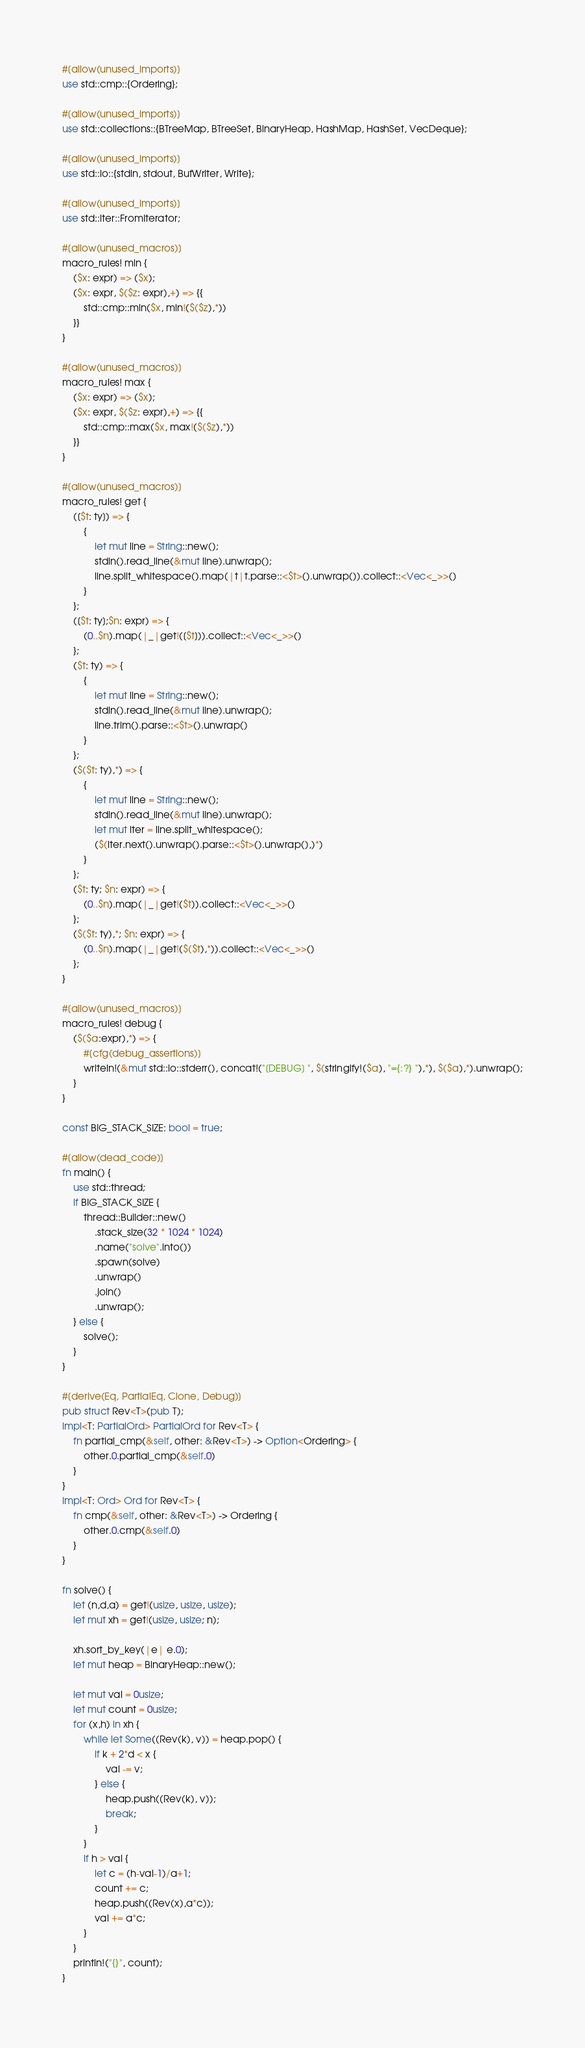Convert code to text. <code><loc_0><loc_0><loc_500><loc_500><_Rust_>#[allow(unused_imports)]
use std::cmp::{Ordering};

#[allow(unused_imports)]
use std::collections::{BTreeMap, BTreeSet, BinaryHeap, HashMap, HashSet, VecDeque};

#[allow(unused_imports)]
use std::io::{stdin, stdout, BufWriter, Write};

#[allow(unused_imports)]
use std::iter::FromIterator;

#[allow(unused_macros)]
macro_rules! min {
    ($x: expr) => ($x);
    ($x: expr, $($z: expr),+) => {{
        std::cmp::min($x, min!($($z),*))
    }}
}

#[allow(unused_macros)]
macro_rules! max {
    ($x: expr) => ($x);
    ($x: expr, $($z: expr),+) => {{
        std::cmp::max($x, max!($($z),*))
    }}
}

#[allow(unused_macros)]
macro_rules! get { 
    ([$t: ty]) => { 
        { 
            let mut line = String::new(); 
            stdin().read_line(&mut line).unwrap(); 
            line.split_whitespace().map(|t|t.parse::<$t>().unwrap()).collect::<Vec<_>>()
        }
    };
    ([$t: ty];$n: expr) => {
        (0..$n).map(|_|get!([$t])).collect::<Vec<_>>()
    };
    ($t: ty) => {
        {
            let mut line = String::new();
            stdin().read_line(&mut line).unwrap();
            line.trim().parse::<$t>().unwrap()
        }
    };
    ($($t: ty),*) => {
        { 
            let mut line = String::new();
            stdin().read_line(&mut line).unwrap();
            let mut iter = line.split_whitespace();
            ($(iter.next().unwrap().parse::<$t>().unwrap(),)*)
        }
    };
    ($t: ty; $n: expr) => {
        (0..$n).map(|_|get!($t)).collect::<Vec<_>>()
    };
    ($($t: ty),*; $n: expr) => {
        (0..$n).map(|_|get!($($t),*)).collect::<Vec<_>>()
    };
}

#[allow(unused_macros)]
macro_rules! debug {
    ($($a:expr),*) => {
        #[cfg(debug_assertions)]
        writeln!(&mut std::io::stderr(), concat!("[DEBUG] ", $(stringify!($a), "={:?} "),*), $($a),*).unwrap();
    }
}

const BIG_STACK_SIZE: bool = true;

#[allow(dead_code)]
fn main() {
    use std::thread;
    if BIG_STACK_SIZE {
        thread::Builder::new()
            .stack_size(32 * 1024 * 1024)
            .name("solve".into())
            .spawn(solve)
            .unwrap()
            .join()
            .unwrap();
    } else {
        solve();
    }
}

#[derive(Eq, PartialEq, Clone, Debug)]
pub struct Rev<T>(pub T);
impl<T: PartialOrd> PartialOrd for Rev<T> {
    fn partial_cmp(&self, other: &Rev<T>) -> Option<Ordering> {
        other.0.partial_cmp(&self.0)
    }
}
impl<T: Ord> Ord for Rev<T> {
    fn cmp(&self, other: &Rev<T>) -> Ordering {
        other.0.cmp(&self.0)
    }
}

fn solve() {
    let (n,d,a) = get!(usize, usize, usize);
    let mut xh = get!(usize, usize; n);

    xh.sort_by_key(|e| e.0); 
    let mut heap = BinaryHeap::new();

    let mut val = 0usize;
    let mut count = 0usize;
    for (x,h) in xh {
        while let Some((Rev(k), v)) = heap.pop() {
            if k + 2*d < x {
                val -= v;
            } else {
                heap.push((Rev(k), v));
                break;
            }
        }
        if h > val {
            let c = (h-val-1)/a+1;
            count += c;
            heap.push((Rev(x),a*c));
            val += a*c;
        }
    }
    println!("{}", count);
}
</code> 